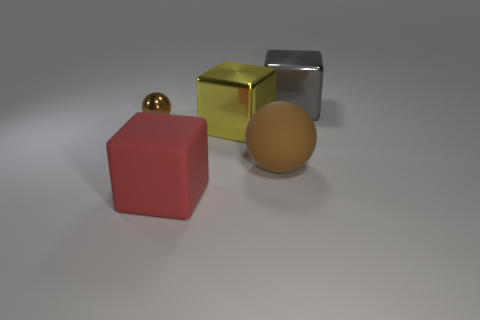Does the rubber ball have the same color as the tiny metal thing?
Your answer should be compact. Yes. There is a metallic cube in front of the gray shiny cube; is it the same size as the shiny sphere?
Offer a terse response. No. There is a large matte object behind the large red thing; is it the same shape as the small object?
Ensure brevity in your answer.  Yes. How many objects are tiny blue things or large cubes behind the red matte cube?
Make the answer very short. 2. Is the number of big gray metallic objects less than the number of large purple balls?
Your answer should be compact. No. Are there more tiny brown metal balls than small blue metal cylinders?
Your response must be concise. Yes. What number of other things are made of the same material as the yellow thing?
Offer a very short reply. 2. There is a block in front of the shiny cube that is left of the big gray cube; what number of large brown matte balls are in front of it?
Make the answer very short. 0. What number of matte things are either brown objects or big red blocks?
Give a very brief answer. 2. What size is the brown ball that is to the left of the big matte thing that is in front of the brown matte thing?
Offer a terse response. Small. 